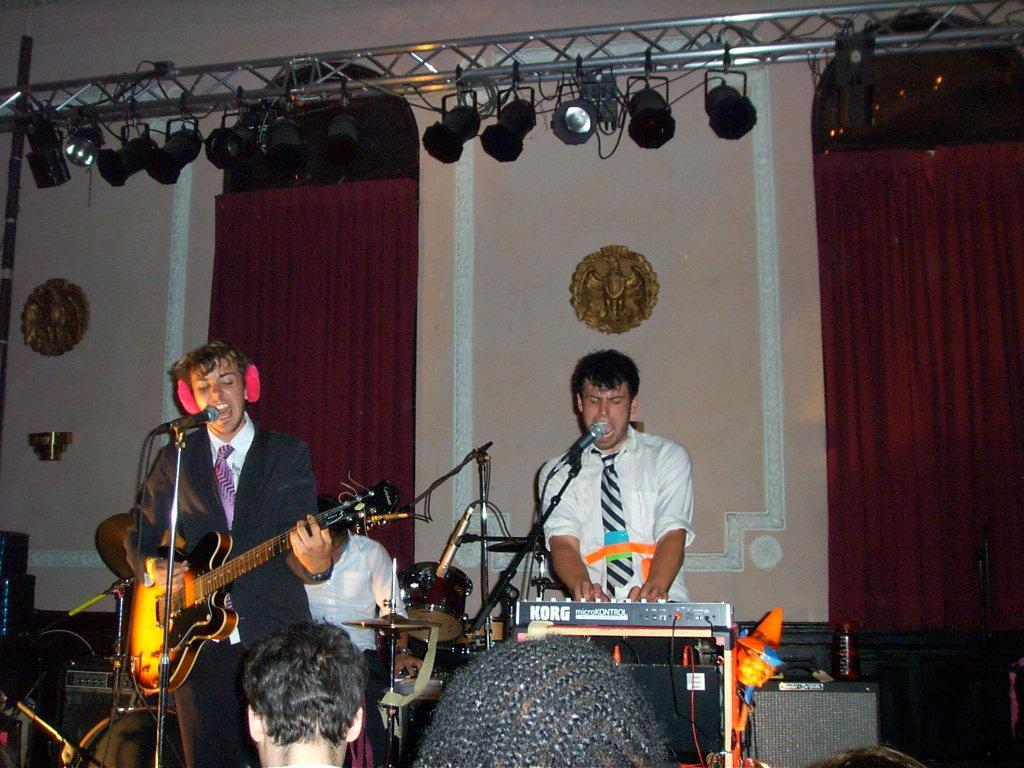Describe this image in one or two sentences. These two persons are standing. This person sitting. This person holding guitar and singing. There is a microphone with stand. These are audience. On the background we can see wall,curtain,focusing lights. 